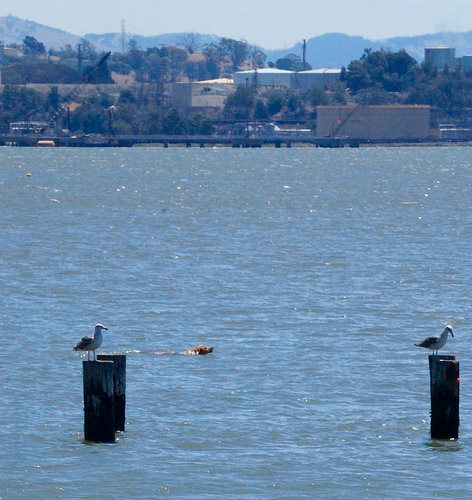<image>
Can you confirm if the sky is behind the mountain? Yes. From this viewpoint, the sky is positioned behind the mountain, with the mountain partially or fully occluding the sky. 